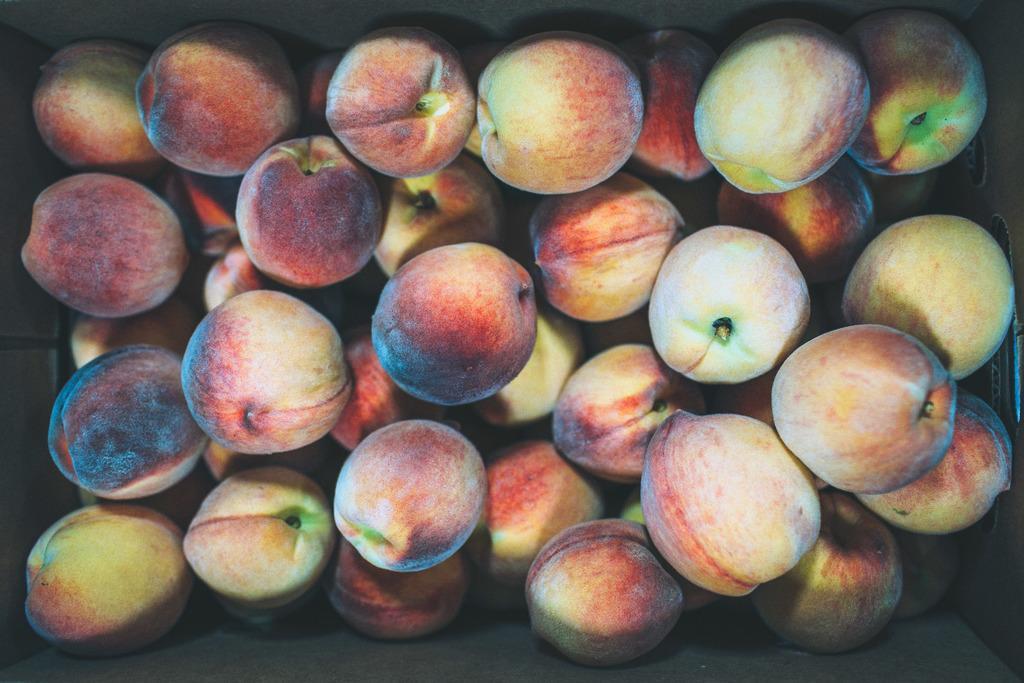Can you describe this image briefly? As we can see in the image there are lot of peaches which are in red in yellowish colour. The peaches are kept in the box. 